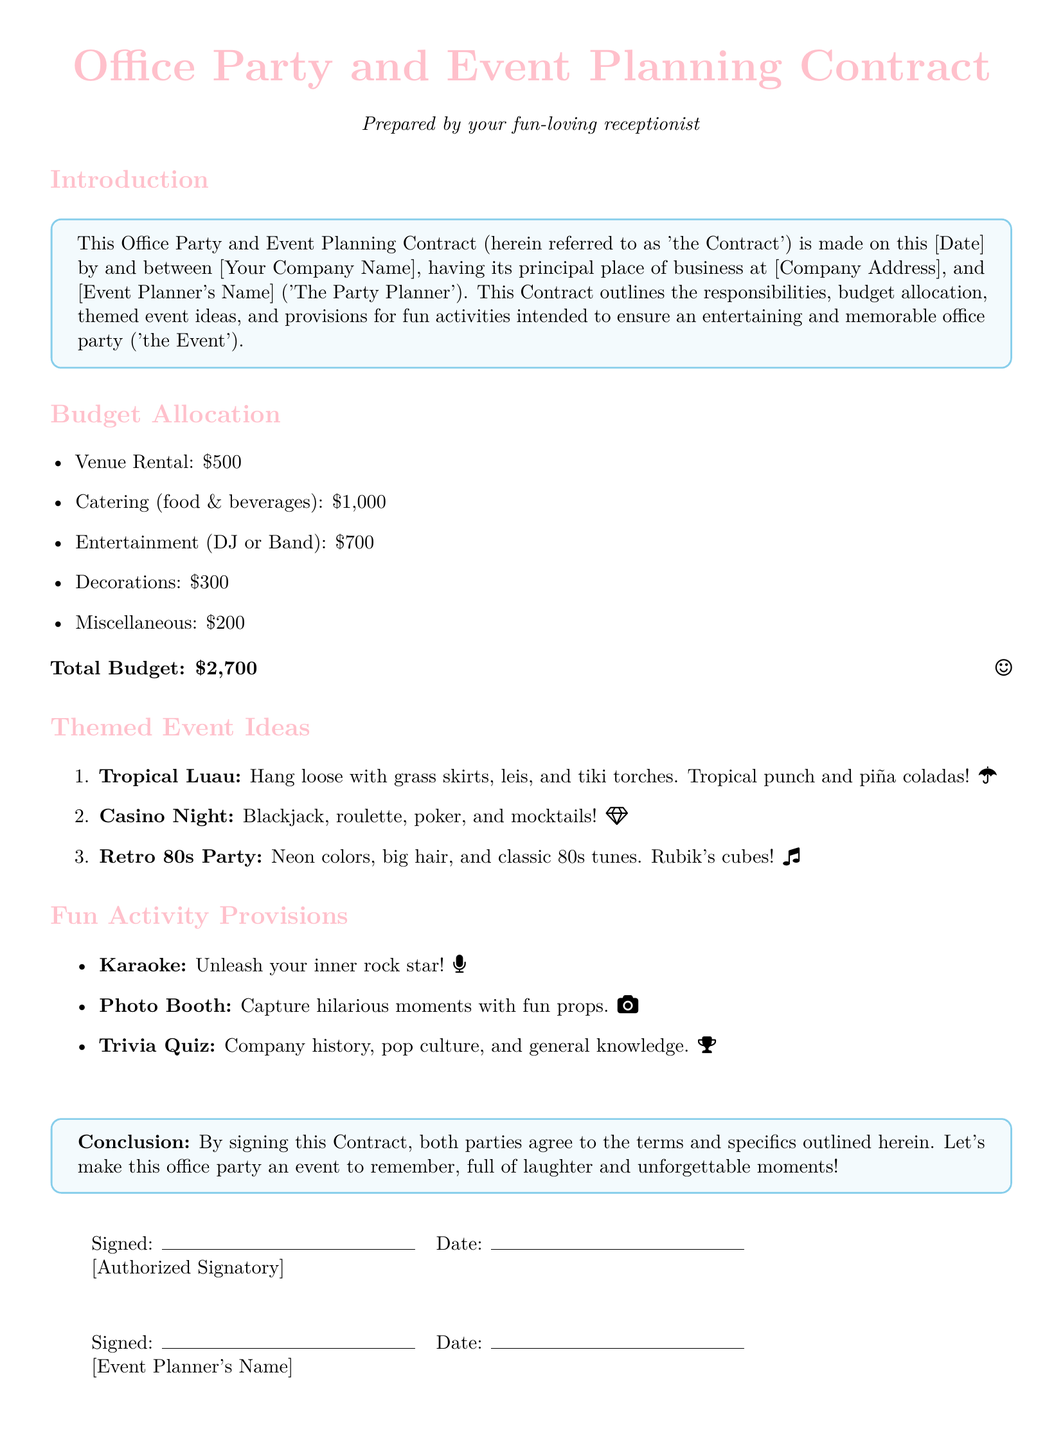What is the total budget? The total budget is explicitly stated in the document, providing a clear sum of all allocated funds.
Answer: $2,700 What is the name of the event planner? The document mentions [Event Planner's Name] as a placeholder for personal information.
Answer: [Event Planner's Name] What are the allocated funds for catering? The document details specific amounts for each budget item, including separate allocations for catering.
Answer: $1,000 Which themed event includes mocktails? The themed events listed in the document describe activities and drinks associated with each theme, including mocktails.
Answer: Casino Night What fun activity involves capturing moments? The document lists various fun activities, one of which is dedicated to capturing memorable moments.
Answer: Photo Booth What is the date format in the document? The placeholders for dates suggest the format for the date when the contract is made.
Answer: [Date] How many themed event ideas are provided? The document includes a numbered list of themed event ideas, which can be quickly counted.
Answer: 3 What is the purpose of the contract? The introduction section summarizes the main goal of the document in organizing an engaging celebratory event.
Answer: Office party 